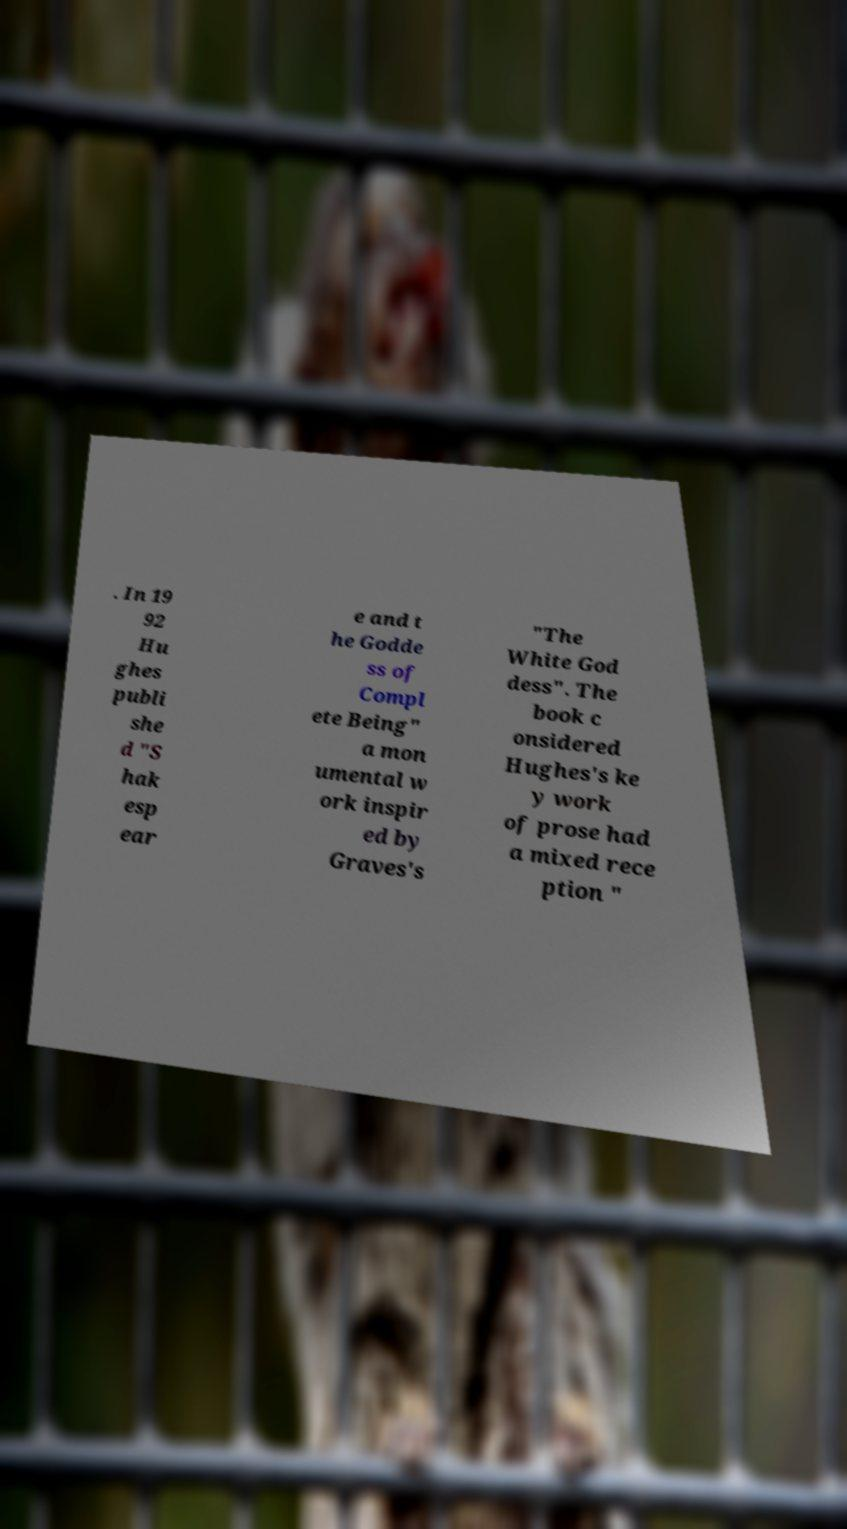Could you extract and type out the text from this image? . In 19 92 Hu ghes publi she d "S hak esp ear e and t he Godde ss of Compl ete Being" a mon umental w ork inspir ed by Graves's "The White God dess". The book c onsidered Hughes's ke y work of prose had a mixed rece ption " 